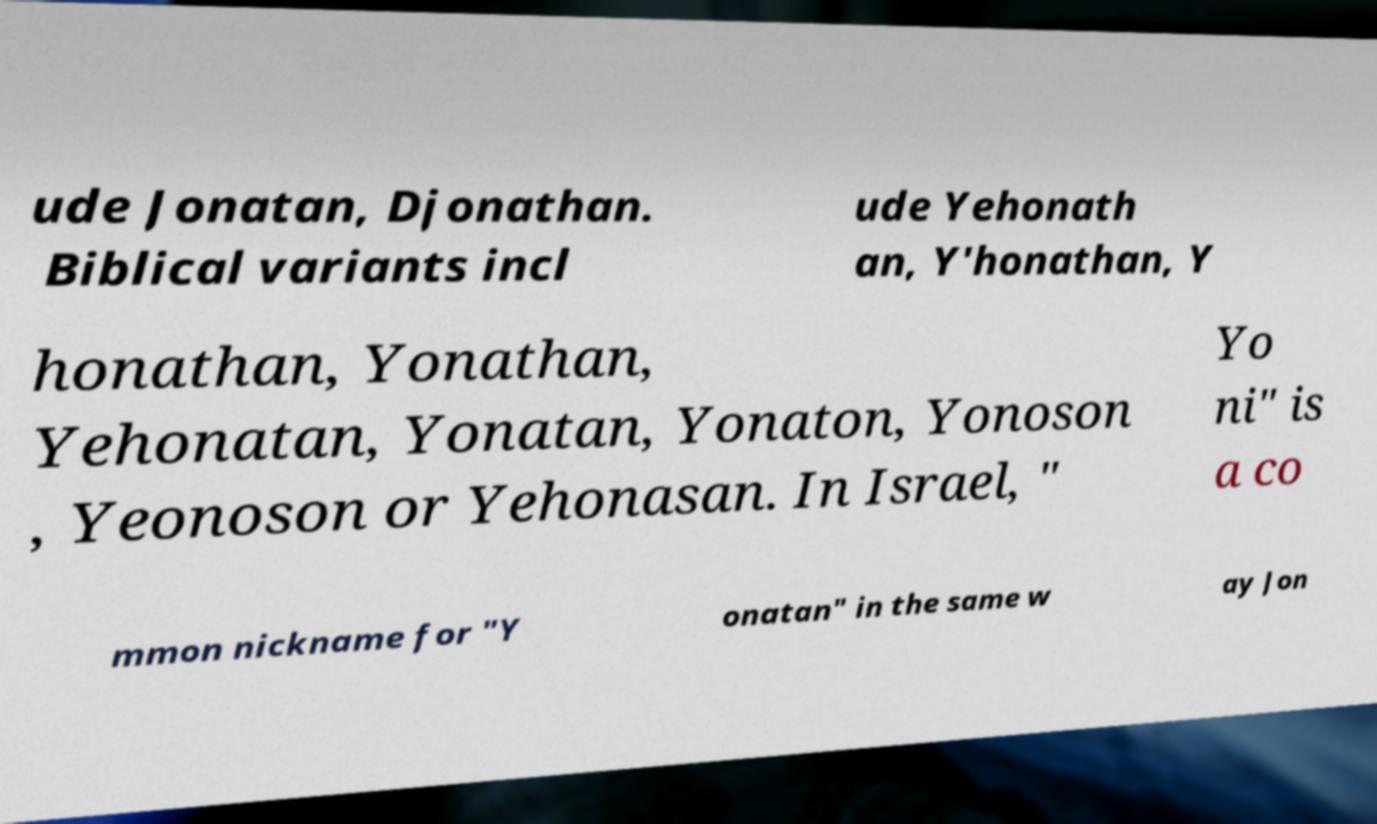Can you accurately transcribe the text from the provided image for me? ude Jonatan, Djonathan. Biblical variants incl ude Yehonath an, Y'honathan, Y honathan, Yonathan, Yehonatan, Yonatan, Yonaton, Yonoson , Yeonoson or Yehonasan. In Israel, " Yo ni" is a co mmon nickname for "Y onatan" in the same w ay Jon 